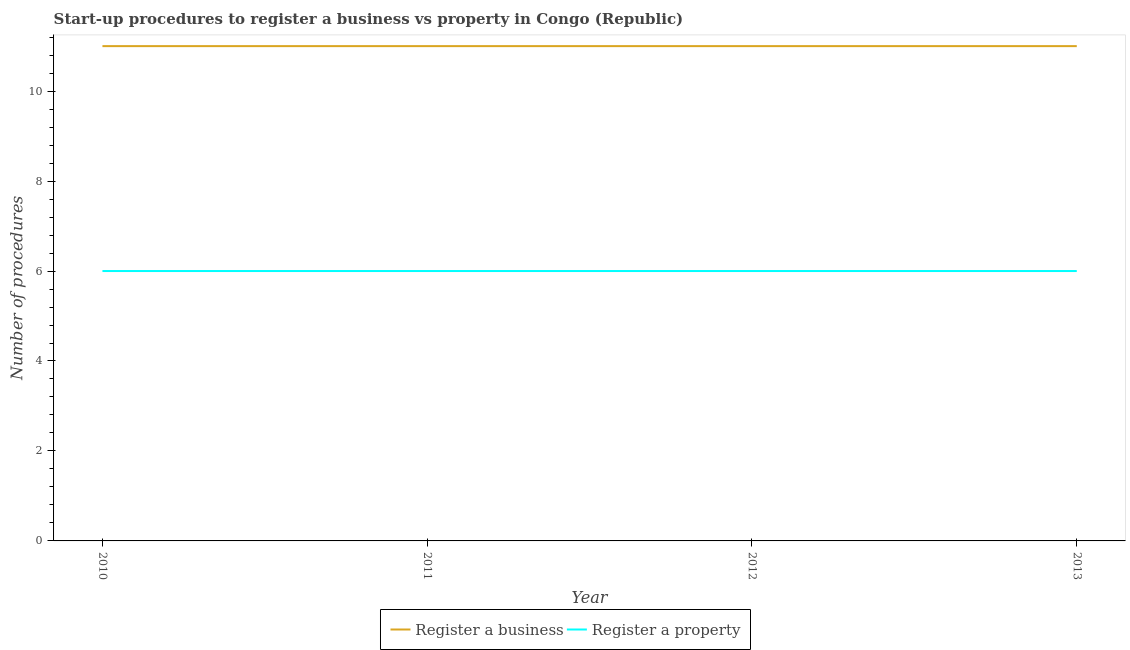How many different coloured lines are there?
Provide a succinct answer. 2. Is the number of lines equal to the number of legend labels?
Provide a short and direct response. Yes. What is the number of procedures to register a business in 2011?
Give a very brief answer. 11. Across all years, what is the maximum number of procedures to register a property?
Provide a short and direct response. 6. Across all years, what is the minimum number of procedures to register a business?
Provide a short and direct response. 11. In which year was the number of procedures to register a business maximum?
Provide a succinct answer. 2010. What is the total number of procedures to register a property in the graph?
Offer a very short reply. 24. What is the difference between the number of procedures to register a property in 2011 and the number of procedures to register a business in 2013?
Offer a terse response. -5. What is the average number of procedures to register a business per year?
Offer a terse response. 11. In the year 2012, what is the difference between the number of procedures to register a business and number of procedures to register a property?
Offer a very short reply. 5. In how many years, is the number of procedures to register a business greater than 3.6?
Ensure brevity in your answer.  4. What is the ratio of the number of procedures to register a business in 2011 to that in 2013?
Provide a short and direct response. 1. Is the difference between the number of procedures to register a property in 2010 and 2013 greater than the difference between the number of procedures to register a business in 2010 and 2013?
Make the answer very short. No. What is the difference between the highest and the lowest number of procedures to register a business?
Provide a succinct answer. 0. Does the number of procedures to register a property monotonically increase over the years?
Your answer should be very brief. No. Is the number of procedures to register a property strictly greater than the number of procedures to register a business over the years?
Your response must be concise. No. How many lines are there?
Your answer should be compact. 2. How many years are there in the graph?
Offer a terse response. 4. Are the values on the major ticks of Y-axis written in scientific E-notation?
Ensure brevity in your answer.  No. Does the graph contain any zero values?
Your answer should be very brief. No. Does the graph contain grids?
Offer a very short reply. No. How are the legend labels stacked?
Keep it short and to the point. Horizontal. What is the title of the graph?
Give a very brief answer. Start-up procedures to register a business vs property in Congo (Republic). Does "Public credit registry" appear as one of the legend labels in the graph?
Provide a short and direct response. No. What is the label or title of the X-axis?
Your response must be concise. Year. What is the label or title of the Y-axis?
Your answer should be very brief. Number of procedures. What is the Number of procedures in Register a business in 2010?
Make the answer very short. 11. What is the Number of procedures in Register a property in 2010?
Your answer should be very brief. 6. What is the Number of procedures in Register a business in 2011?
Provide a short and direct response. 11. What is the Number of procedures of Register a property in 2012?
Provide a succinct answer. 6. What is the Number of procedures of Register a business in 2013?
Offer a very short reply. 11. Across all years, what is the minimum Number of procedures in Register a property?
Provide a short and direct response. 6. What is the difference between the Number of procedures of Register a business in 2010 and that in 2011?
Ensure brevity in your answer.  0. What is the difference between the Number of procedures in Register a business in 2010 and that in 2012?
Your response must be concise. 0. What is the difference between the Number of procedures of Register a business in 2010 and that in 2013?
Your answer should be very brief. 0. What is the difference between the Number of procedures in Register a property in 2010 and that in 2013?
Keep it short and to the point. 0. What is the difference between the Number of procedures in Register a property in 2011 and that in 2012?
Your answer should be very brief. 0. What is the difference between the Number of procedures of Register a property in 2011 and that in 2013?
Your answer should be compact. 0. What is the difference between the Number of procedures in Register a business in 2012 and that in 2013?
Provide a succinct answer. 0. What is the difference between the Number of procedures in Register a property in 2012 and that in 2013?
Your response must be concise. 0. What is the difference between the Number of procedures of Register a business in 2010 and the Number of procedures of Register a property in 2011?
Provide a short and direct response. 5. What is the difference between the Number of procedures of Register a business in 2010 and the Number of procedures of Register a property in 2012?
Ensure brevity in your answer.  5. What is the average Number of procedures in Register a business per year?
Your answer should be compact. 11. What is the average Number of procedures of Register a property per year?
Offer a very short reply. 6. In the year 2010, what is the difference between the Number of procedures in Register a business and Number of procedures in Register a property?
Make the answer very short. 5. In the year 2013, what is the difference between the Number of procedures in Register a business and Number of procedures in Register a property?
Provide a short and direct response. 5. What is the ratio of the Number of procedures of Register a business in 2010 to that in 2011?
Offer a very short reply. 1. What is the ratio of the Number of procedures of Register a business in 2010 to that in 2012?
Keep it short and to the point. 1. What is the ratio of the Number of procedures in Register a property in 2011 to that in 2012?
Ensure brevity in your answer.  1. What is the ratio of the Number of procedures in Register a property in 2011 to that in 2013?
Your answer should be very brief. 1. What is the ratio of the Number of procedures in Register a property in 2012 to that in 2013?
Your answer should be very brief. 1. What is the difference between the highest and the second highest Number of procedures in Register a business?
Ensure brevity in your answer.  0. What is the difference between the highest and the second highest Number of procedures in Register a property?
Make the answer very short. 0. 